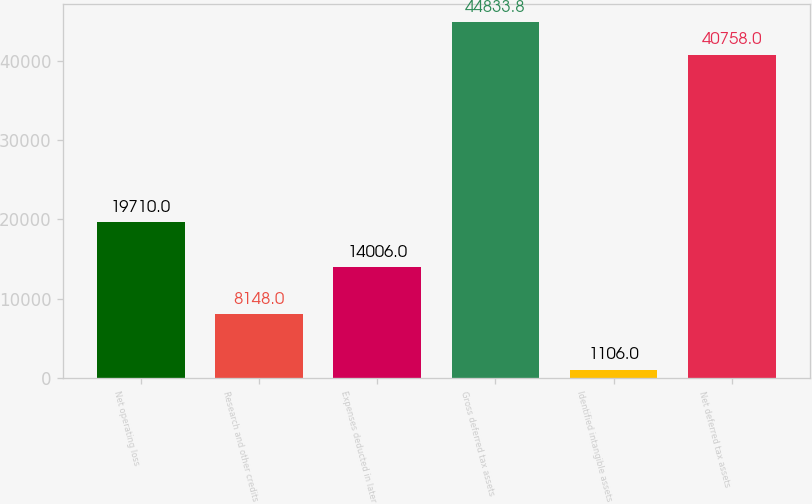Convert chart. <chart><loc_0><loc_0><loc_500><loc_500><bar_chart><fcel>Net operating loss<fcel>Research and other credits<fcel>Expenses deducted in later<fcel>Gross deferred tax assets<fcel>Identified intangible assets<fcel>Net deferred tax assets<nl><fcel>19710<fcel>8148<fcel>14006<fcel>44833.8<fcel>1106<fcel>40758<nl></chart> 